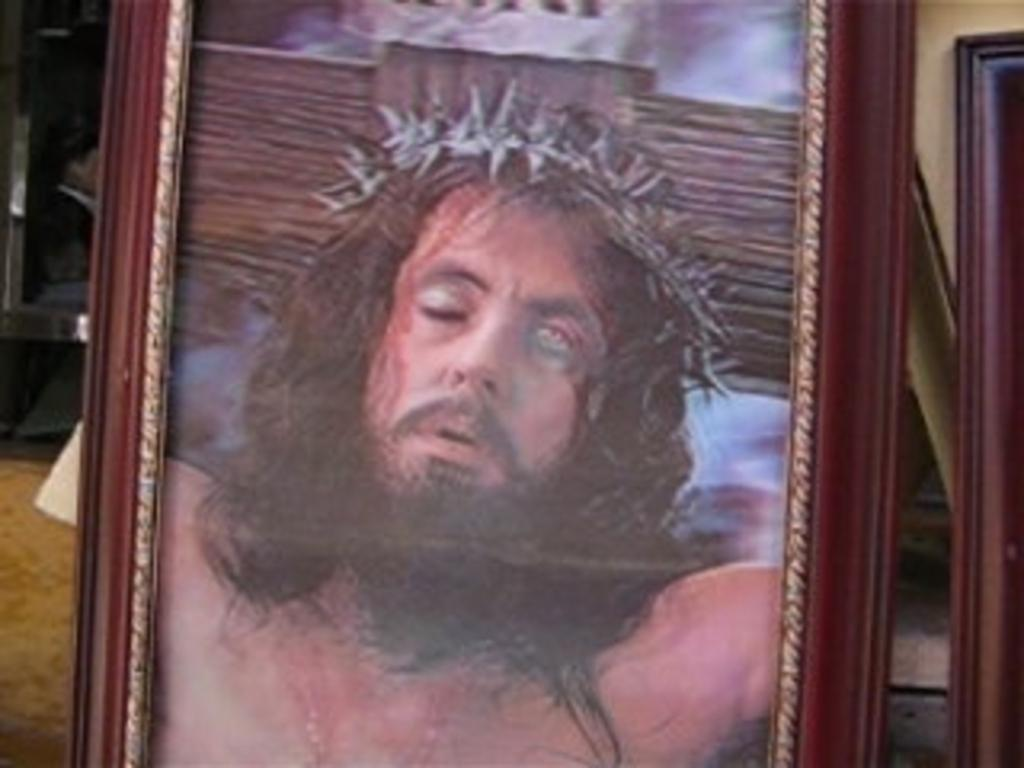What objects are present in the image? There are frames in the image. What can be found within the frames? There is a picture of a person on one of the frames. What type of drum is being played in the image? There is no drum present in the image; it only features frames with a picture of a person. 